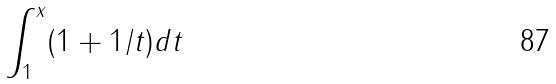Convert formula to latex. <formula><loc_0><loc_0><loc_500><loc_500>\int _ { 1 } ^ { x } ( 1 + 1 / t ) d t</formula> 